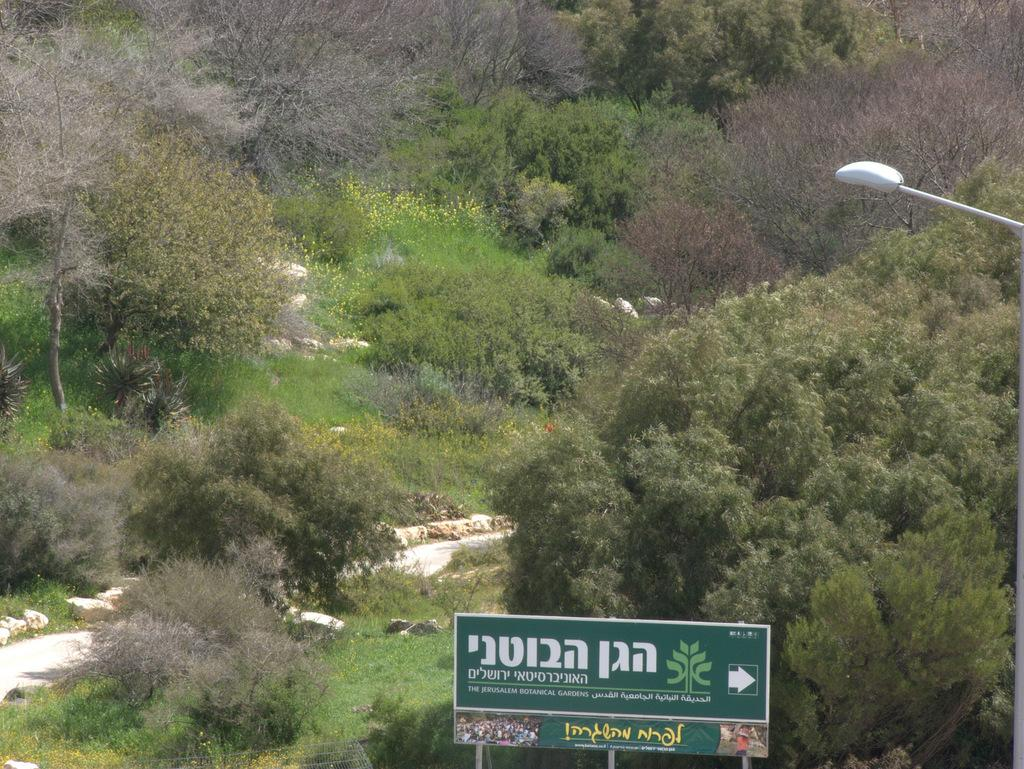What type of natural elements can be seen in the image? There are trees in the image. What is the source of illumination in the image? There is a light source in the image. What material is the rod in the image made of? The rod in the image is made of metal. What is located at the bottom of the image? There is a sign board at the bottom of the image. What type of shock can be seen in the image? There is no shock present in the image. What type of thread is being used to create the trees in the image? The trees in the image are natural elements and do not involve any thread. 